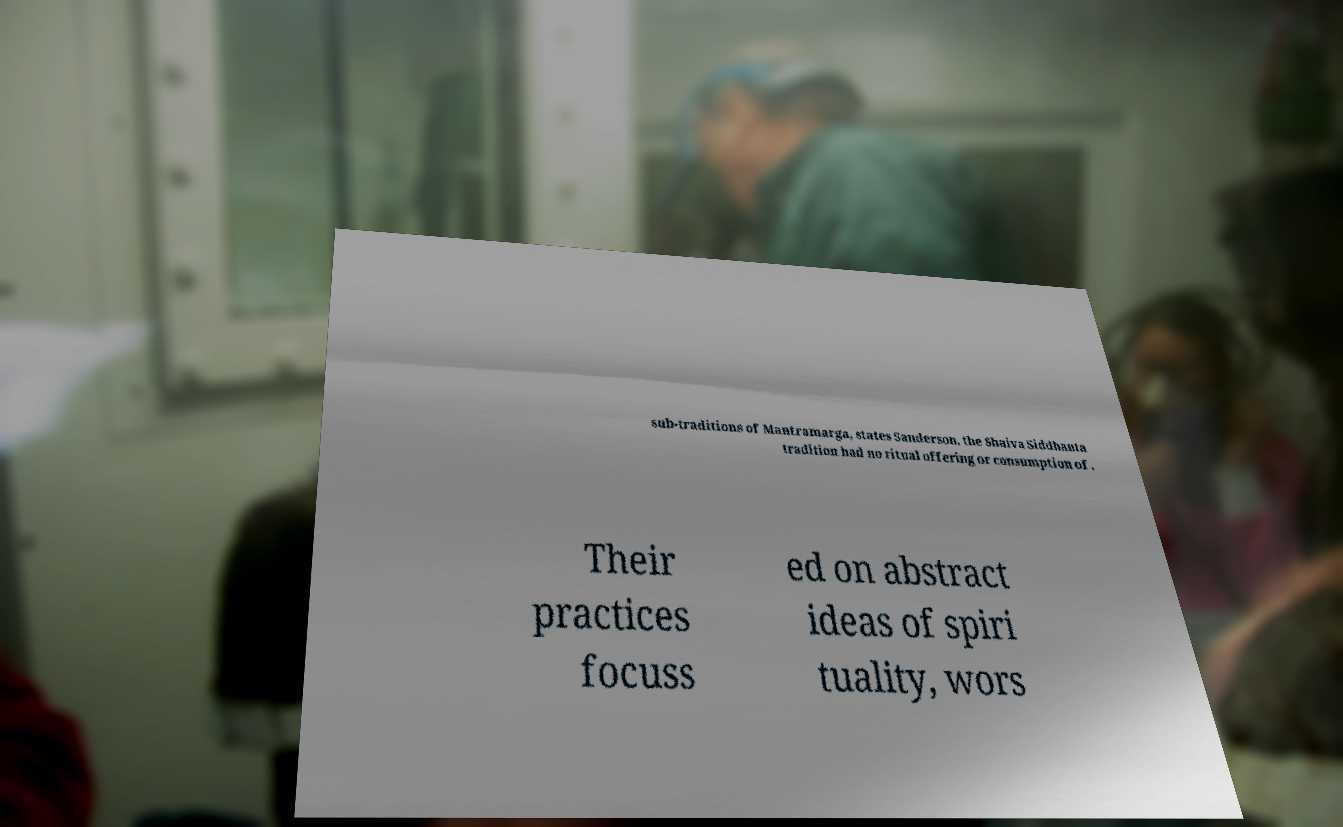Can you read and provide the text displayed in the image?This photo seems to have some interesting text. Can you extract and type it out for me? sub-traditions of Mantramarga, states Sanderson, the Shaiva Siddhanta tradition had no ritual offering or consumption of . Their practices focuss ed on abstract ideas of spiri tuality, wors 